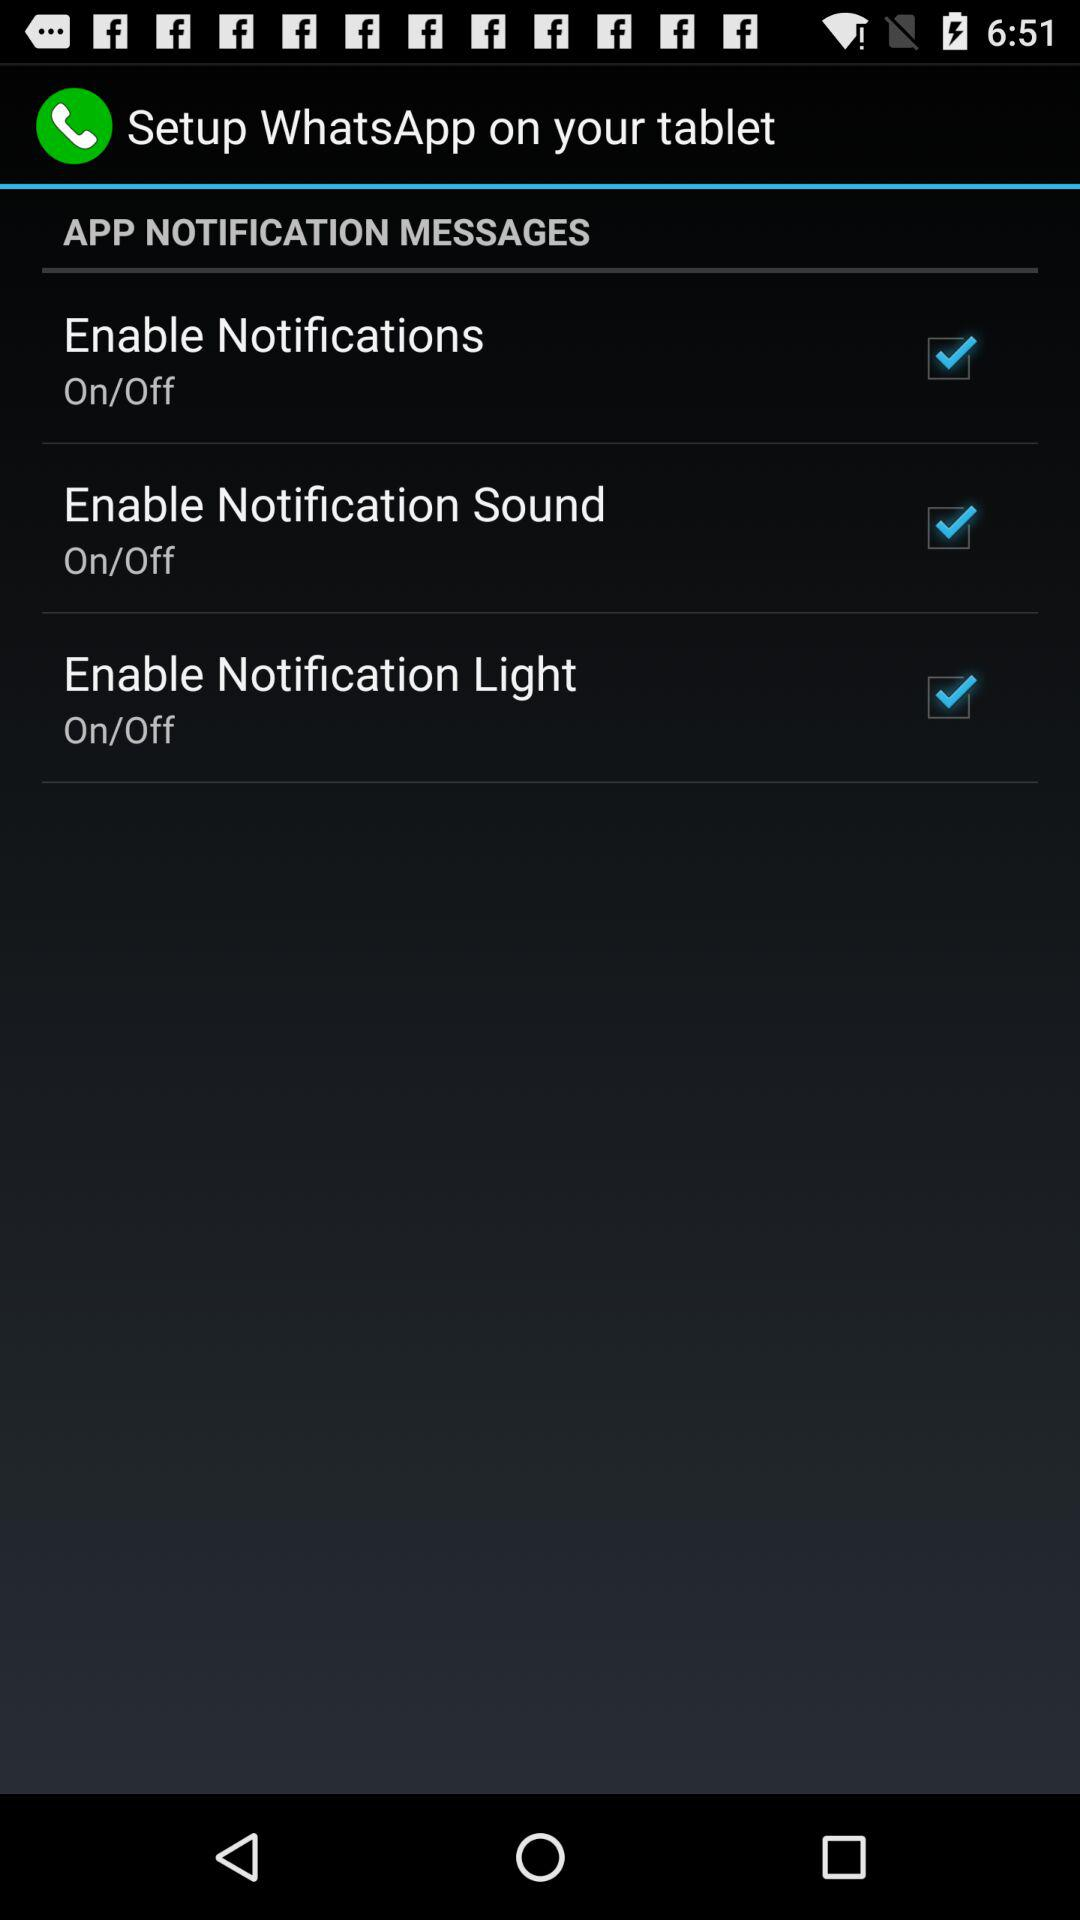What are the different notifications? The different notifications are "Enable Notifications", "Enable Notification Sound" and "Enable Notification Light". 